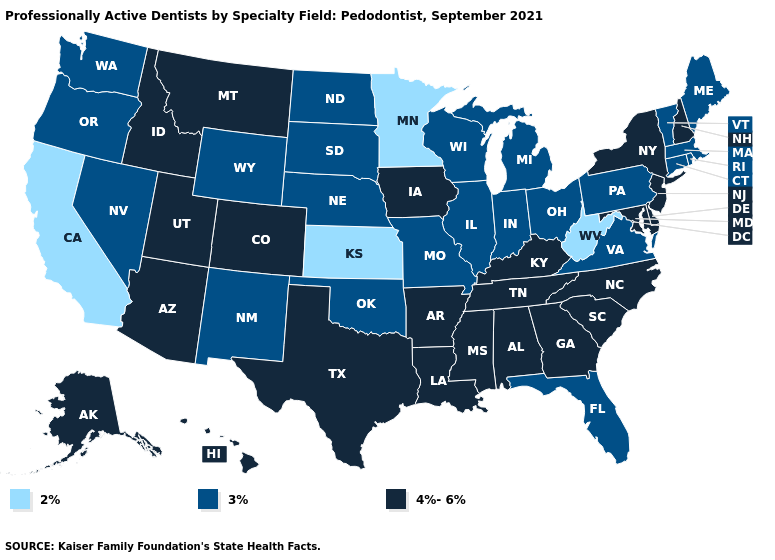Which states have the highest value in the USA?
Answer briefly. Alabama, Alaska, Arizona, Arkansas, Colorado, Delaware, Georgia, Hawaii, Idaho, Iowa, Kentucky, Louisiana, Maryland, Mississippi, Montana, New Hampshire, New Jersey, New York, North Carolina, South Carolina, Tennessee, Texas, Utah. What is the value of Montana?
Quick response, please. 4%-6%. Is the legend a continuous bar?
Write a very short answer. No. What is the value of Kentucky?
Concise answer only. 4%-6%. Which states have the highest value in the USA?
Keep it brief. Alabama, Alaska, Arizona, Arkansas, Colorado, Delaware, Georgia, Hawaii, Idaho, Iowa, Kentucky, Louisiana, Maryland, Mississippi, Montana, New Hampshire, New Jersey, New York, North Carolina, South Carolina, Tennessee, Texas, Utah. Name the states that have a value in the range 2%?
Answer briefly. California, Kansas, Minnesota, West Virginia. Does the map have missing data?
Quick response, please. No. What is the value of Massachusetts?
Keep it brief. 3%. What is the highest value in the USA?
Write a very short answer. 4%-6%. Does Massachusetts have the highest value in the Northeast?
Quick response, please. No. How many symbols are there in the legend?
Be succinct. 3. Name the states that have a value in the range 4%-6%?
Write a very short answer. Alabama, Alaska, Arizona, Arkansas, Colorado, Delaware, Georgia, Hawaii, Idaho, Iowa, Kentucky, Louisiana, Maryland, Mississippi, Montana, New Hampshire, New Jersey, New York, North Carolina, South Carolina, Tennessee, Texas, Utah. Among the states that border Illinois , which have the highest value?
Keep it brief. Iowa, Kentucky. What is the value of Florida?
Concise answer only. 3%. Does the map have missing data?
Write a very short answer. No. 